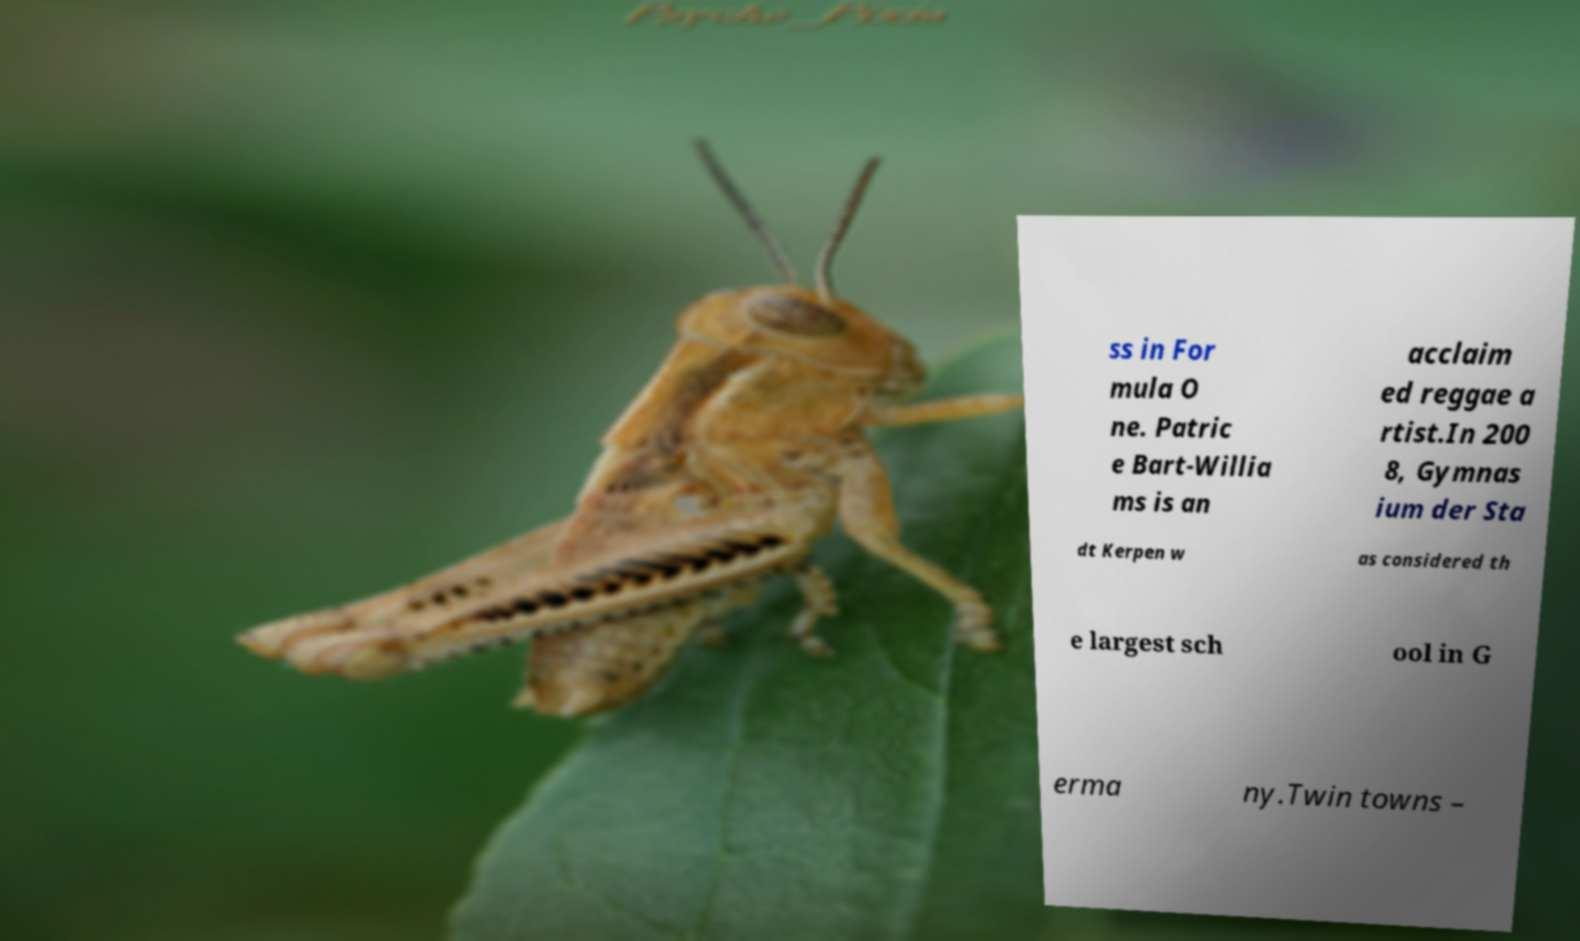For documentation purposes, I need the text within this image transcribed. Could you provide that? ss in For mula O ne. Patric e Bart-Willia ms is an acclaim ed reggae a rtist.In 200 8, Gymnas ium der Sta dt Kerpen w as considered th e largest sch ool in G erma ny.Twin towns – 